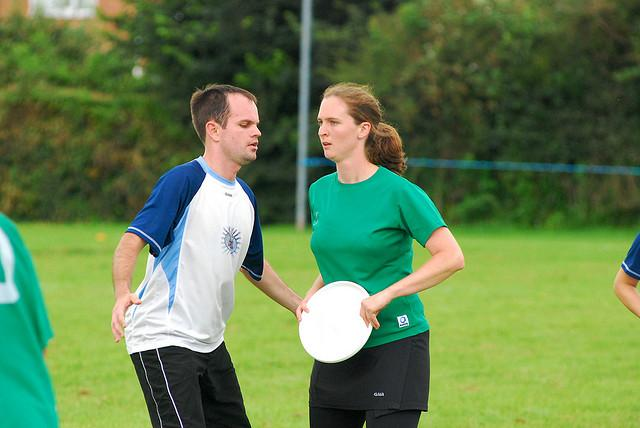The man in blue wants to do what to the frisbee holder?

Choices:
A) assist her
B) block her
C) nothing
D) embarrass her block her 